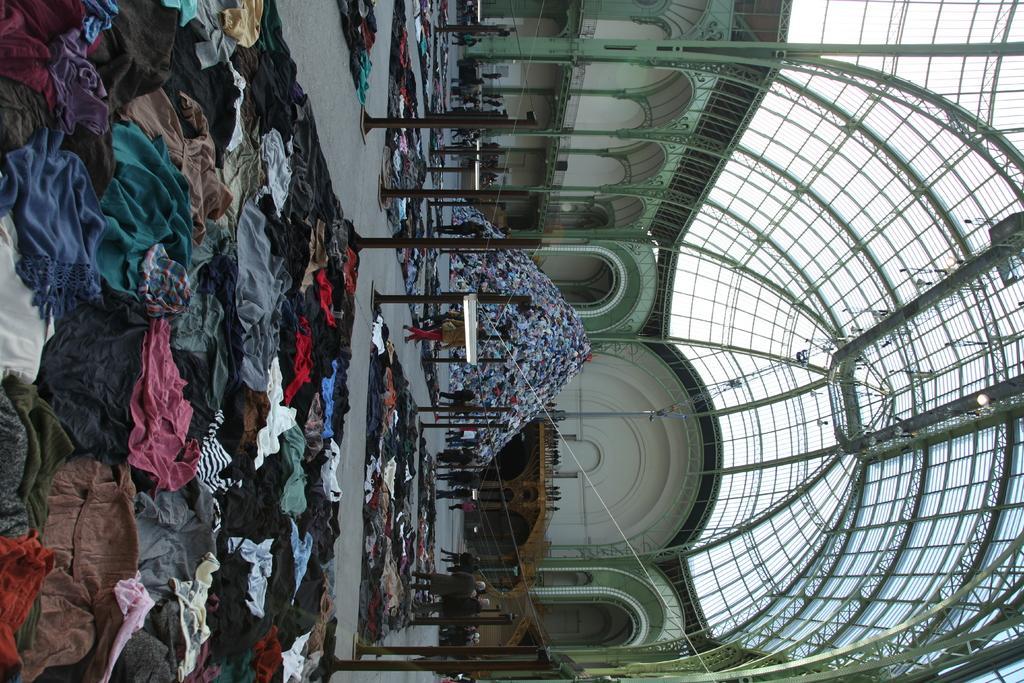Can you describe this image briefly? This image is rotated to the left. I can see a pile of clothes, poles, clothes arranged on the floor, a metal rooftop of a building, some people walking in this image. 